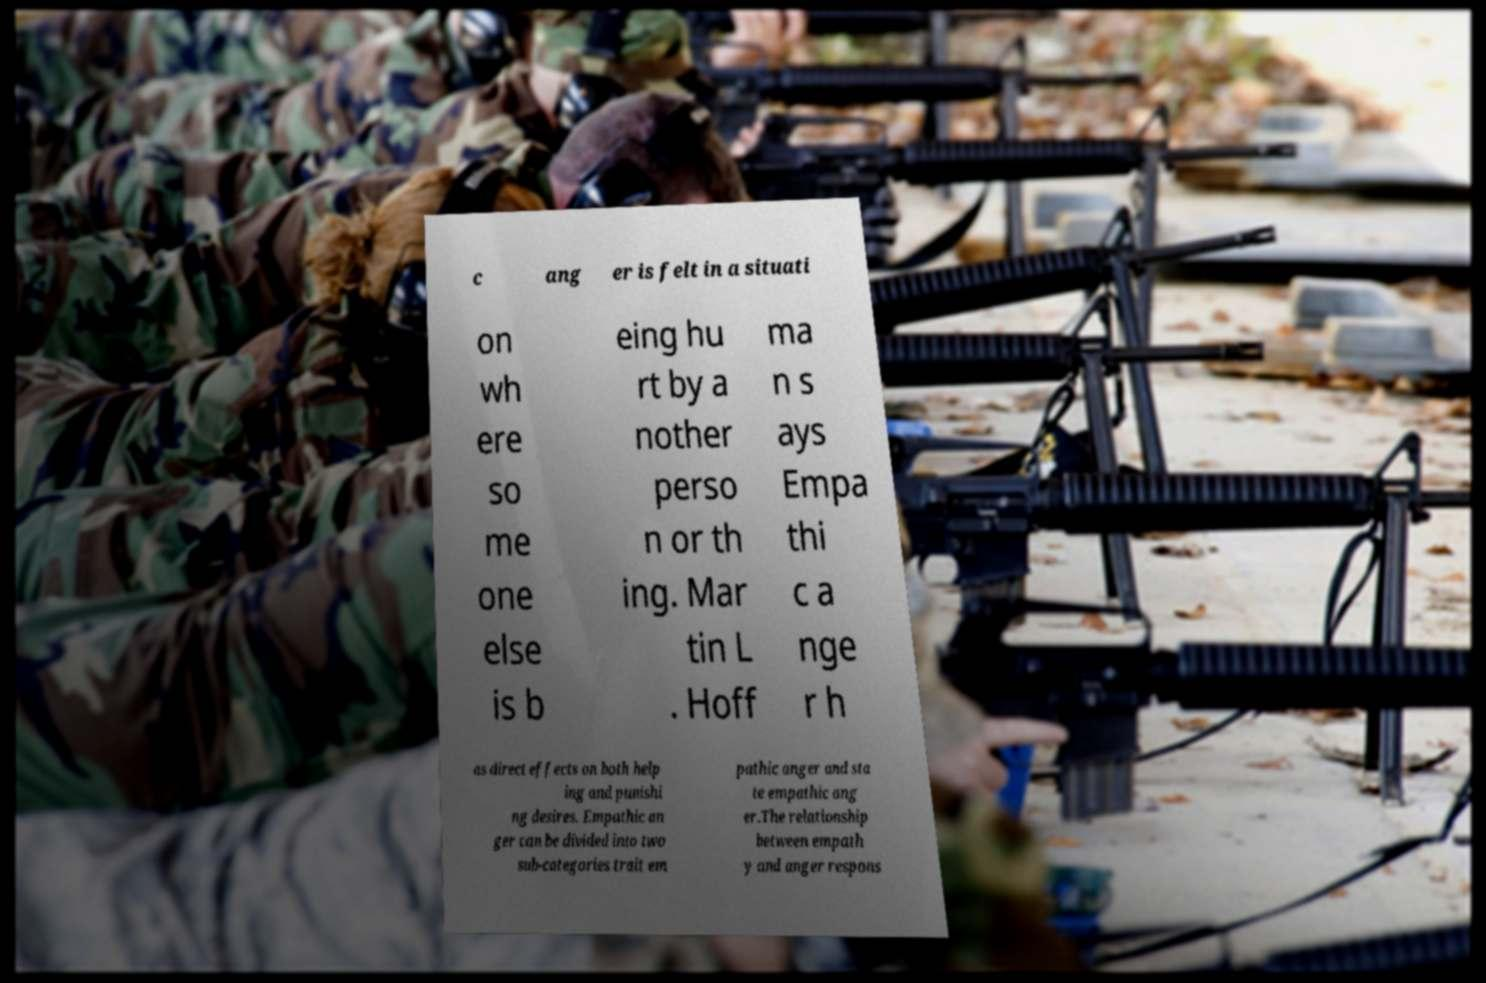I need the written content from this picture converted into text. Can you do that? c ang er is felt in a situati on wh ere so me one else is b eing hu rt by a nother perso n or th ing. Mar tin L . Hoff ma n s ays Empa thi c a nge r h as direct effects on both help ing and punishi ng desires. Empathic an ger can be divided into two sub-categories trait em pathic anger and sta te empathic ang er.The relationship between empath y and anger respons 